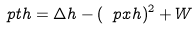Convert formula to latex. <formula><loc_0><loc_0><loc_500><loc_500>\ p t h = \Delta h - ( \ p x h ) ^ { 2 } + W</formula> 